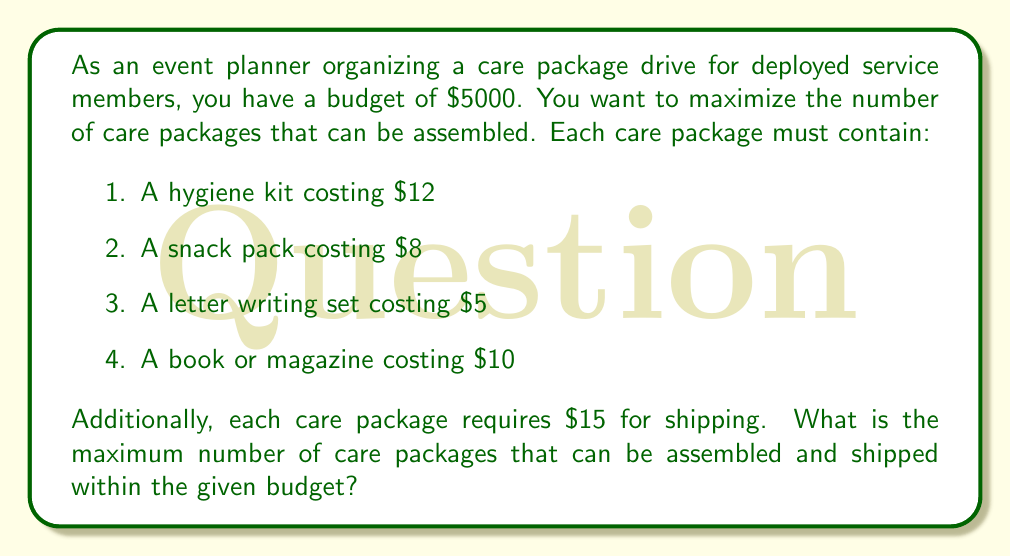Solve this math problem. To solve this problem, we need to follow these steps:

1. Calculate the total cost of one care package:
   $$\text{Cost per package} = 12 + 8 + 5 + 10 + 15 = $50$$

2. Set up an equation to represent the problem:
   Let $x$ be the number of care packages.
   $$50x \leq 5000$$

3. Solve the inequality:
   $$x \leq \frac{5000}{50} = 100$$

4. Since we can't have a fractional number of care packages, we need to round down to the nearest whole number.

Therefore, the maximum number of care packages that can be assembled and shipped within the budget is 100.

To verify:
$$100 \text{ packages} \times $50 \text{ per package} = $5000$$

This utilizes the entire budget and maximizes the number of care packages.
Answer: The maximum number of care packages that can be assembled and shipped within the given budget is 100. 